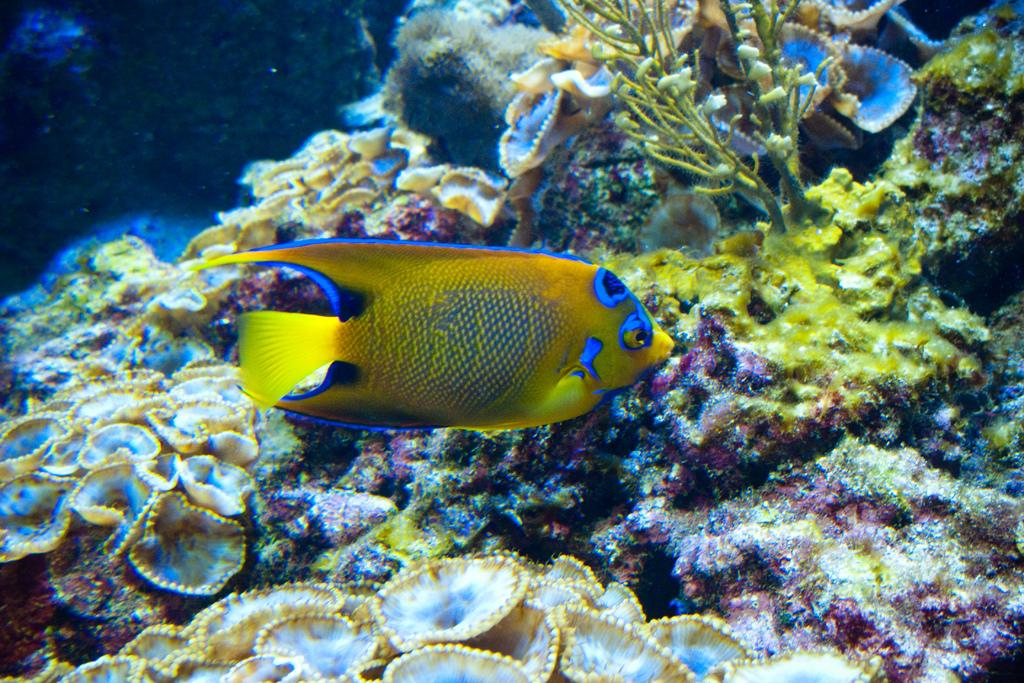What type of environment is depicted in the image? The image is an underwater picture. What can be seen among the aquatic plants in the image? There is a fish in the image. Can you describe the appearance of the fish? The fish is yellow, blue, and black in color. How many bikes are visible in the underwater image? There are no bikes present in the underwater image. What type of thing is the fish swimming around in the image? The fish is swimming in water, not around a "thing." 